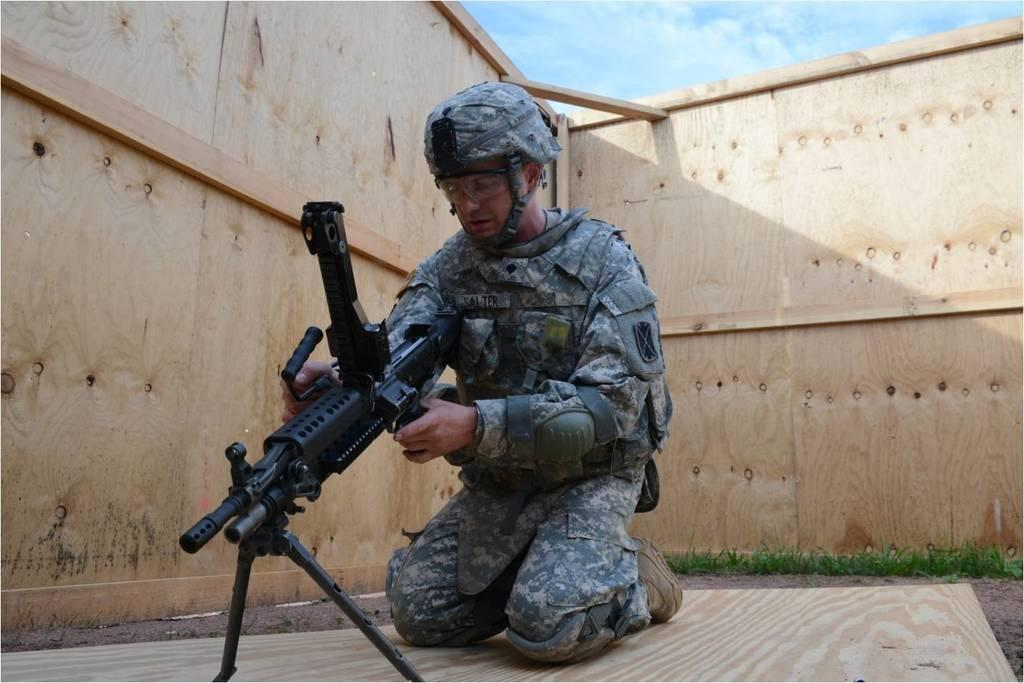What is the man in the image doing? The man is sitting on his knees in the image. What is the man holding in the image? The man is holding a gun in the image. What protective gear is the man wearing? The man is wearing a helmet in the image. What accessory is the man wearing on his face? The man is wearing glasses in the image. What other gun can be seen in the image? There is a gun with a stand in the image. What type of natural environment is visible in the background of the image? There is grass in the background of the image. What can be seen in the sky in the image? There are clouds in the sky in the image. How many zippers are visible on the man's clothing in the image? There are no zippers visible on the man's clothing in the image. What type of flock is flying in the sky in the image? There are no birds or flocks visible in the sky in the image. 